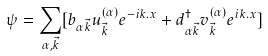Convert formula to latex. <formula><loc_0><loc_0><loc_500><loc_500>\psi = \sum _ { \alpha , \vec { k } } [ b _ { \alpha \vec { k } } u _ { \vec { k } } ^ { ( \alpha ) } e ^ { - i k . x } + d ^ { \dagger } _ { \alpha \vec { k } } v _ { \vec { k } } ^ { ( \alpha ) } e ^ { i k . x } ]</formula> 